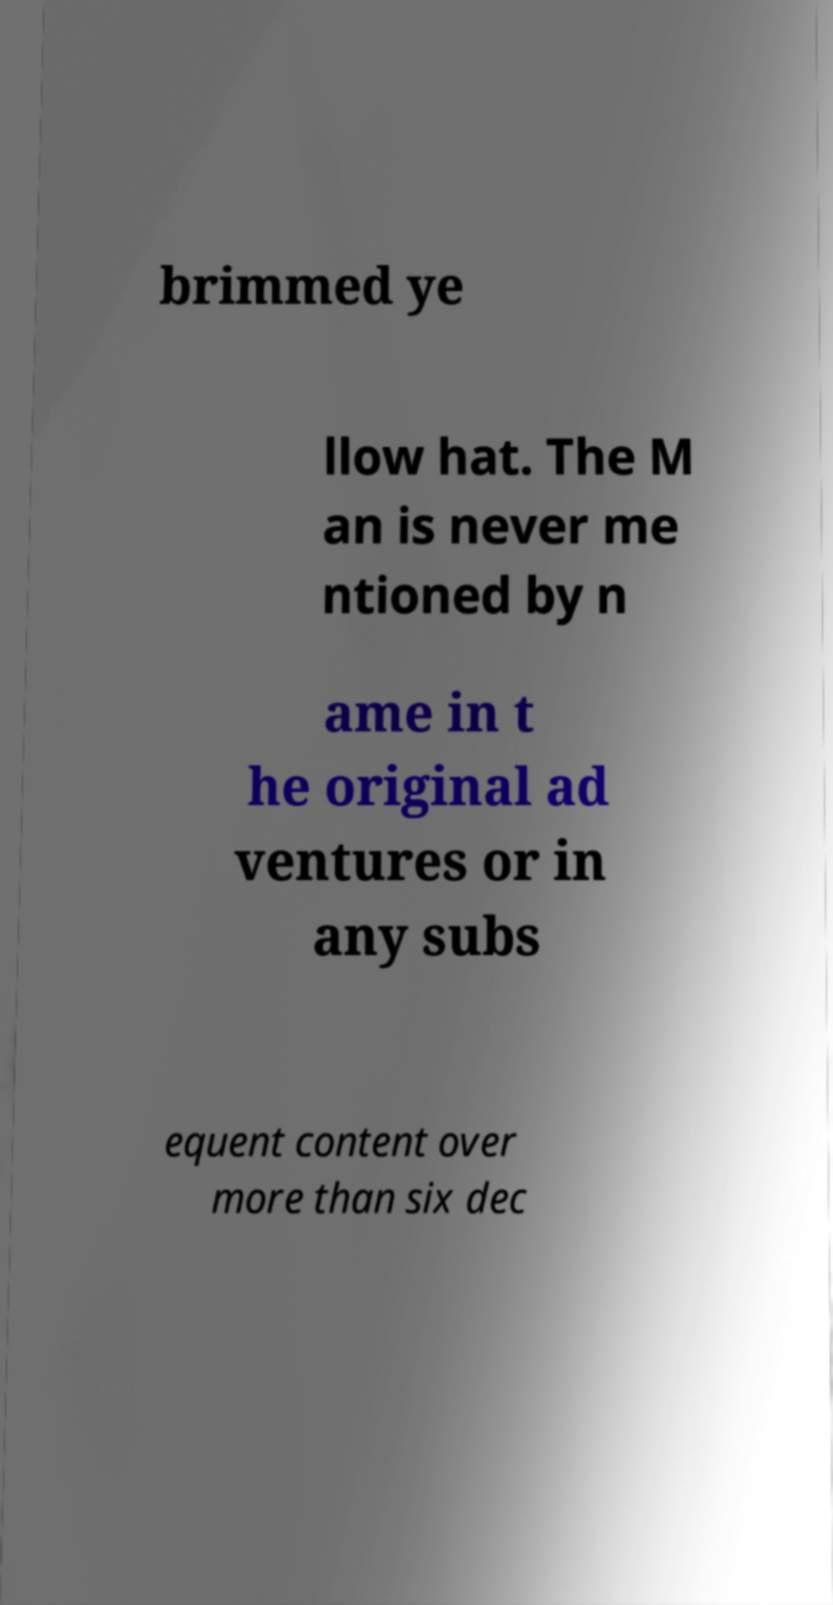Could you extract and type out the text from this image? brimmed ye llow hat. The M an is never me ntioned by n ame in t he original ad ventures or in any subs equent content over more than six dec 